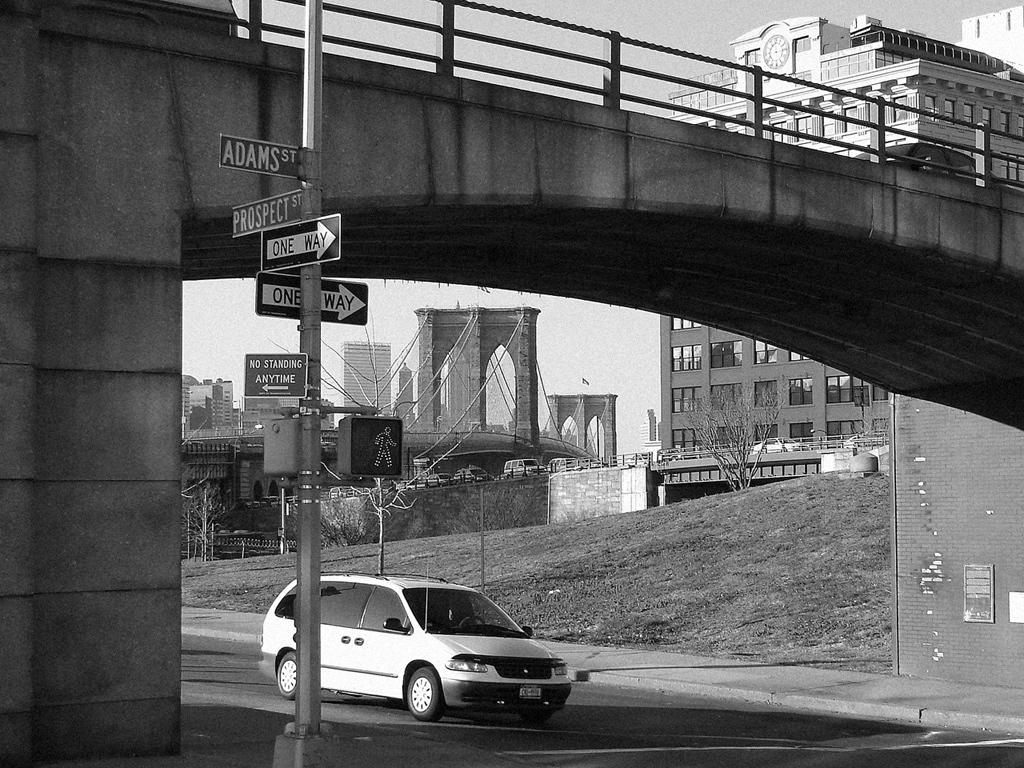<image>
Present a compact description of the photo's key features. A car is waiting at a cross walk at the intersection of Adams St and Prospect St. 